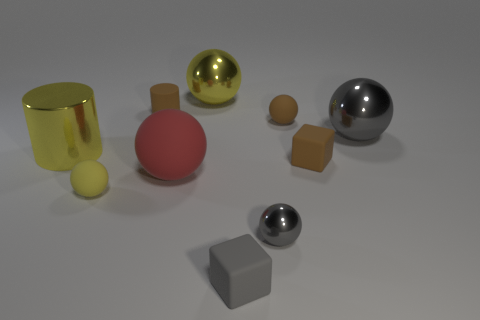Subtract all red spheres. How many spheres are left? 5 Subtract all big red balls. How many balls are left? 5 Subtract all red spheres. Subtract all green cubes. How many spheres are left? 5 Subtract all cylinders. How many objects are left? 8 Subtract 0 green blocks. How many objects are left? 10 Subtract all tiny gray cylinders. Subtract all small matte things. How many objects are left? 5 Add 6 small yellow spheres. How many small yellow spheres are left? 7 Add 8 large gray metallic objects. How many large gray metallic objects exist? 9 